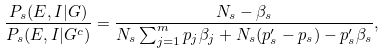Convert formula to latex. <formula><loc_0><loc_0><loc_500><loc_500>\frac { P _ { s } ( E , I | G ) } { P _ { s } ( E , I | G ^ { c } ) } = \frac { N _ { s } - \beta _ { s } } { N _ { s } \sum _ { j = 1 } ^ { m } p _ { j } \beta _ { j } + N _ { s } ( p _ { s } ^ { \prime } - p _ { s } ) - p _ { s } ^ { \prime } \beta _ { s } } ,</formula> 